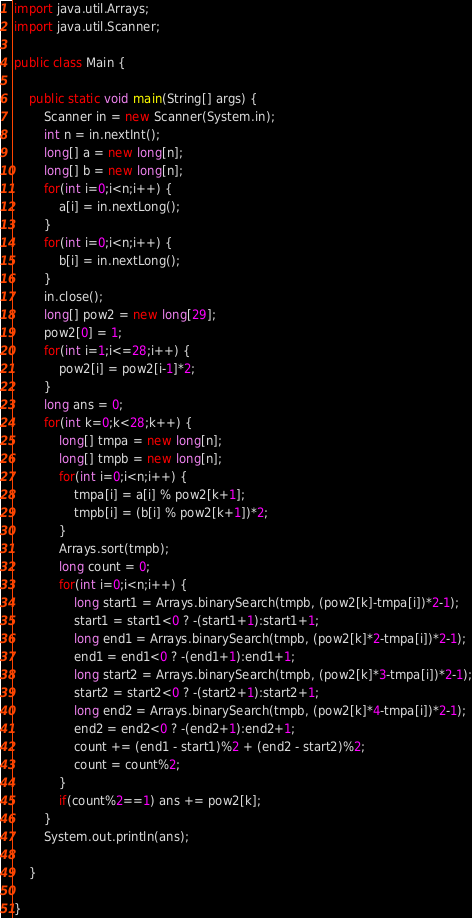Convert code to text. <code><loc_0><loc_0><loc_500><loc_500><_Java_>import java.util.Arrays;
import java.util.Scanner;

public class Main {

	public static void main(String[] args) {
		Scanner in = new Scanner(System.in);
		int n = in.nextInt();
		long[] a = new long[n];
		long[] b = new long[n];
		for(int i=0;i<n;i++) {
			a[i] = in.nextLong();
		}
		for(int i=0;i<n;i++) {
			b[i] = in.nextLong();
		}
		in.close();
		long[] pow2 = new long[29];
		pow2[0] = 1;
		for(int i=1;i<=28;i++) {
			pow2[i] = pow2[i-1]*2;
		}
		long ans = 0;
		for(int k=0;k<28;k++) {
			long[] tmpa = new long[n];
			long[] tmpb = new long[n];
			for(int i=0;i<n;i++) {
				tmpa[i] = a[i] % pow2[k+1];
				tmpb[i] = (b[i] % pow2[k+1])*2;
			}
			Arrays.sort(tmpb);
			long count = 0;
			for(int i=0;i<n;i++) {
				long start1 = Arrays.binarySearch(tmpb, (pow2[k]-tmpa[i])*2-1);
				start1 = start1<0 ? -(start1+1):start1+1;
				long end1 = Arrays.binarySearch(tmpb, (pow2[k]*2-tmpa[i])*2-1);
				end1 = end1<0 ? -(end1+1):end1+1;
				long start2 = Arrays.binarySearch(tmpb, (pow2[k]*3-tmpa[i])*2-1);
				start2 = start2<0 ? -(start2+1):start2+1;
				long end2 = Arrays.binarySearch(tmpb, (pow2[k]*4-tmpa[i])*2-1);
				end2 = end2<0 ? -(end2+1):end2+1;
				count += (end1 - start1)%2 + (end2 - start2)%2;
				count = count%2;
			}
			if(count%2==1) ans += pow2[k];
		}
		System.out.println(ans);

	}

}
</code> 